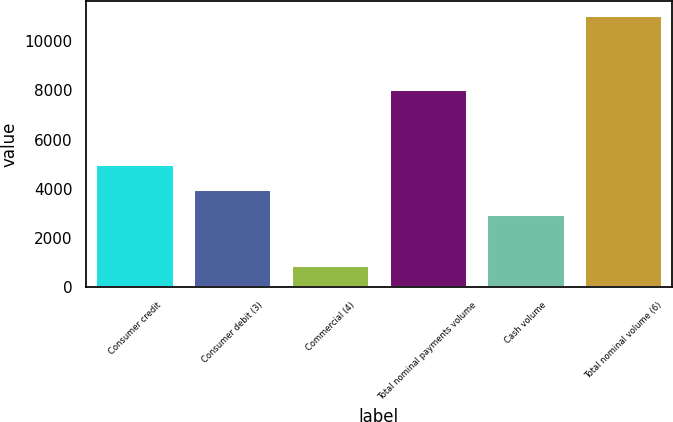Convert chart to OTSL. <chart><loc_0><loc_0><loc_500><loc_500><bar_chart><fcel>Consumer credit<fcel>Consumer debit (3)<fcel>Commercial (4)<fcel>Total nominal payments volume<fcel>Cash volume<fcel>Total nominal volume (6)<nl><fcel>5024<fcel>4010.5<fcel>925<fcel>8063<fcel>2997<fcel>11060<nl></chart> 